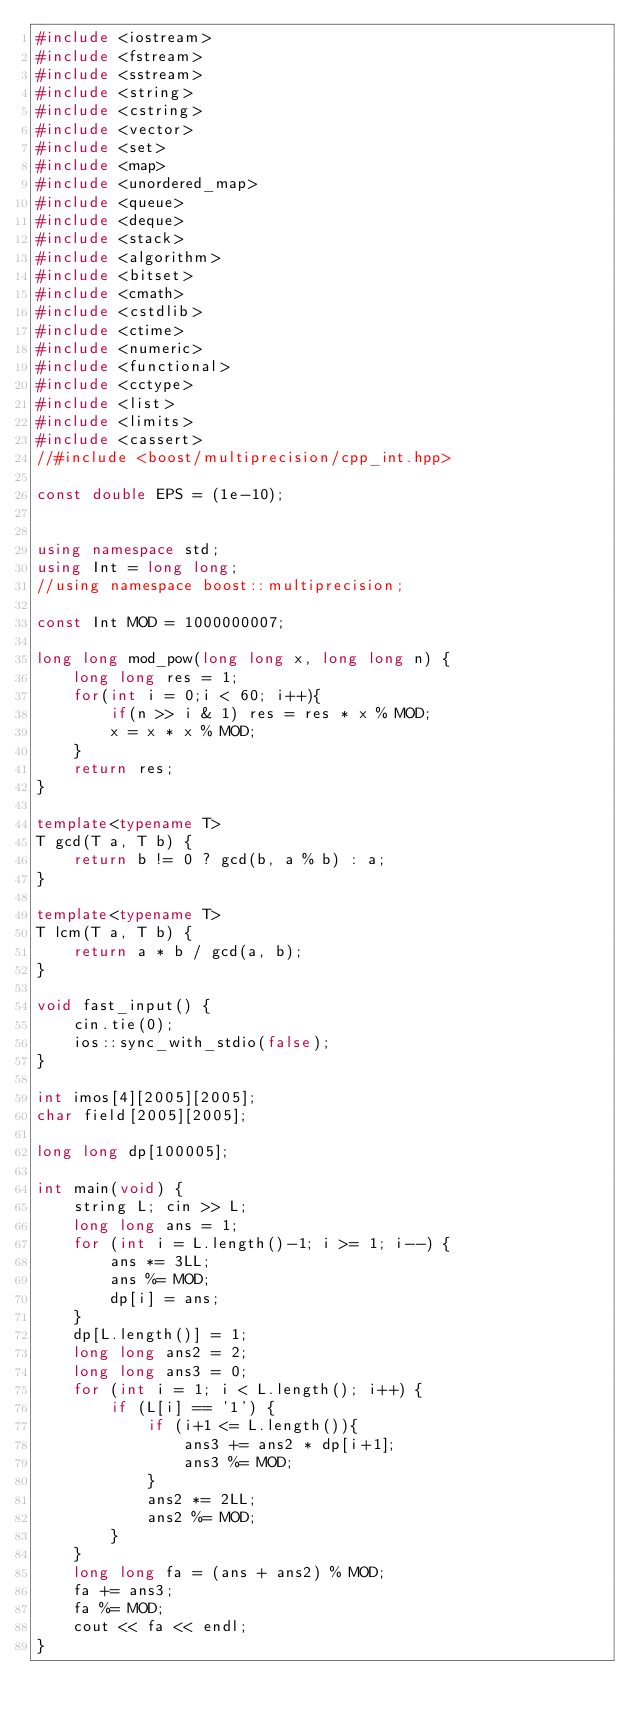Convert code to text. <code><loc_0><loc_0><loc_500><loc_500><_C++_>#include <iostream>
#include <fstream>
#include <sstream>
#include <string>
#include <cstring>
#include <vector>
#include <set>
#include <map>
#include <unordered_map>
#include <queue>
#include <deque>
#include <stack>
#include <algorithm>
#include <bitset>
#include <cmath>
#include <cstdlib>
#include <ctime>
#include <numeric>
#include <functional>
#include <cctype>
#include <list>
#include <limits>
#include <cassert>
//#include <boost/multiprecision/cpp_int.hpp>

const double EPS = (1e-10);


using namespace std;
using Int = long long;
//using namespace boost::multiprecision;

const Int MOD = 1000000007;

long long mod_pow(long long x, long long n) {
    long long res = 1;
    for(int i = 0;i < 60; i++){
        if(n >> i & 1) res = res * x % MOD;
        x = x * x % MOD;
    }
    return res;
}

template<typename T>
T gcd(T a, T b) {
    return b != 0 ? gcd(b, a % b) : a;
}

template<typename T>
T lcm(T a, T b) {
    return a * b / gcd(a, b);
}

void fast_input() {
    cin.tie(0);
    ios::sync_with_stdio(false);
}

int imos[4][2005][2005];
char field[2005][2005];

long long dp[100005];

int main(void) {
    string L; cin >> L;
    long long ans = 1;
    for (int i = L.length()-1; i >= 1; i--) {
        ans *= 3LL;
        ans %= MOD;
        dp[i] = ans;
    }
    dp[L.length()] = 1;
    long long ans2 = 2;
    long long ans3 = 0;
    for (int i = 1; i < L.length(); i++) {
        if (L[i] == '1') {
            if (i+1 <= L.length()){
                ans3 += ans2 * dp[i+1];
                ans3 %= MOD;                
            }
            ans2 *= 2LL;
            ans2 %= MOD;
        }
    }
    long long fa = (ans + ans2) % MOD;
    fa += ans3;
    fa %= MOD;
    cout << fa << endl;
}   
</code> 